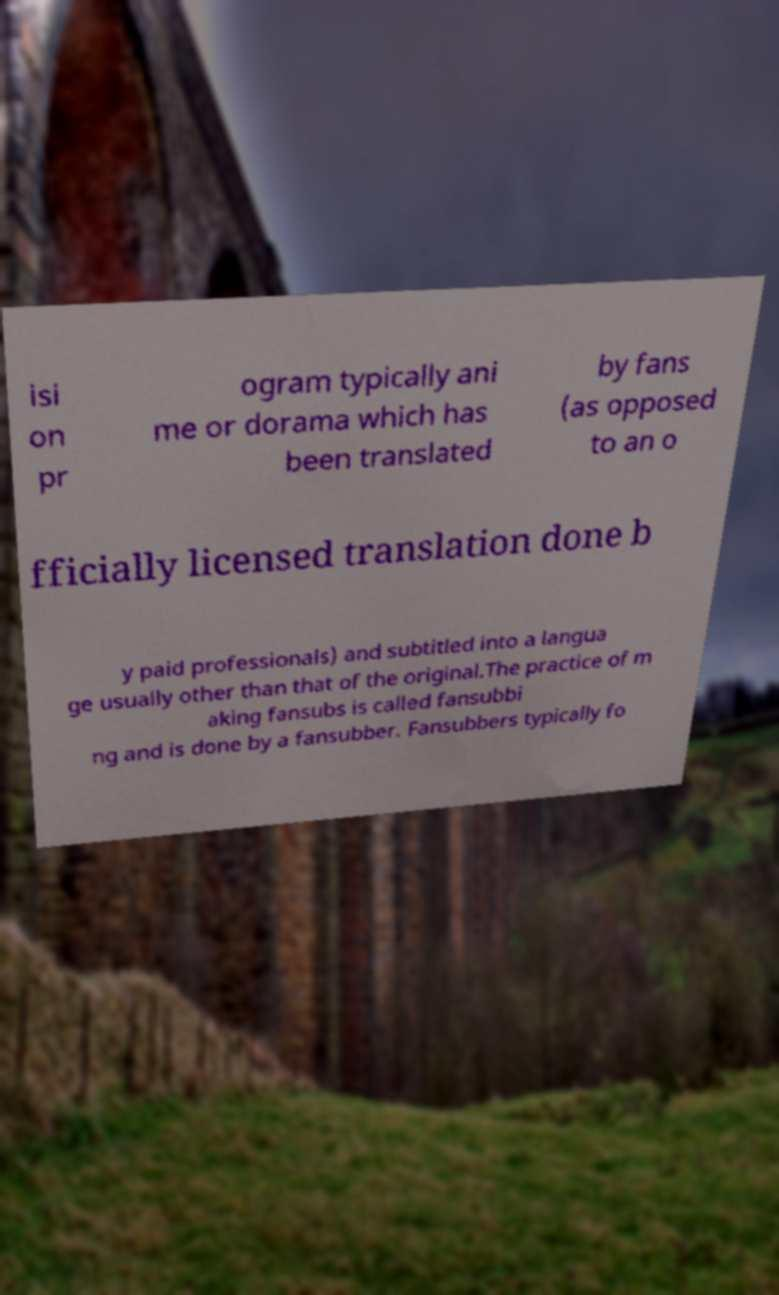Please identify and transcribe the text found in this image. isi on pr ogram typically ani me or dorama which has been translated by fans (as opposed to an o fficially licensed translation done b y paid professionals) and subtitled into a langua ge usually other than that of the original.The practice of m aking fansubs is called fansubbi ng and is done by a fansubber. Fansubbers typically fo 